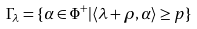<formula> <loc_0><loc_0><loc_500><loc_500>\Gamma _ { \lambda } = \{ \alpha \in \Phi ^ { + } | \langle \lambda + \rho , \alpha \rangle \geq p \}</formula> 